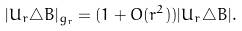Convert formula to latex. <formula><loc_0><loc_0><loc_500><loc_500>| U _ { r } \triangle B | _ { g _ { r } } = ( 1 + O ( r ^ { 2 } ) ) | U _ { r } \triangle B | .</formula> 